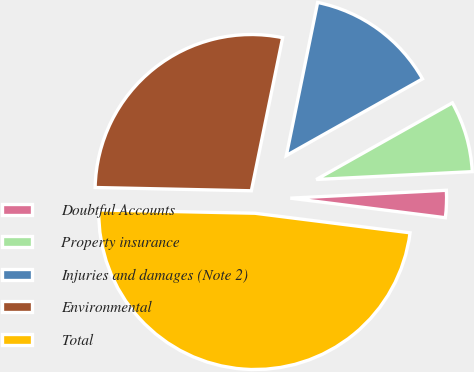Convert chart. <chart><loc_0><loc_0><loc_500><loc_500><pie_chart><fcel>Doubtful Accounts<fcel>Property insurance<fcel>Injuries and damages (Note 2)<fcel>Environmental<fcel>Total<nl><fcel>2.8%<fcel>7.36%<fcel>13.63%<fcel>27.88%<fcel>48.34%<nl></chart> 